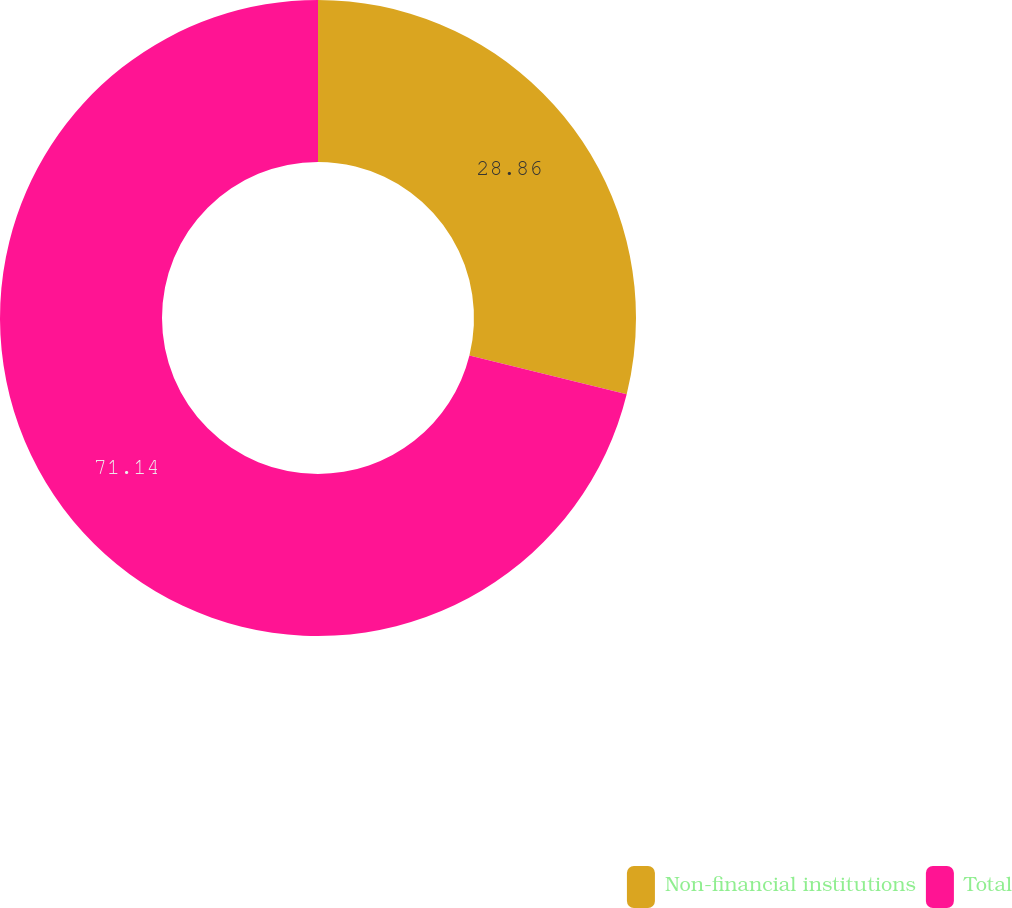Convert chart. <chart><loc_0><loc_0><loc_500><loc_500><pie_chart><fcel>Non-financial institutions<fcel>Total<nl><fcel>28.86%<fcel>71.14%<nl></chart> 